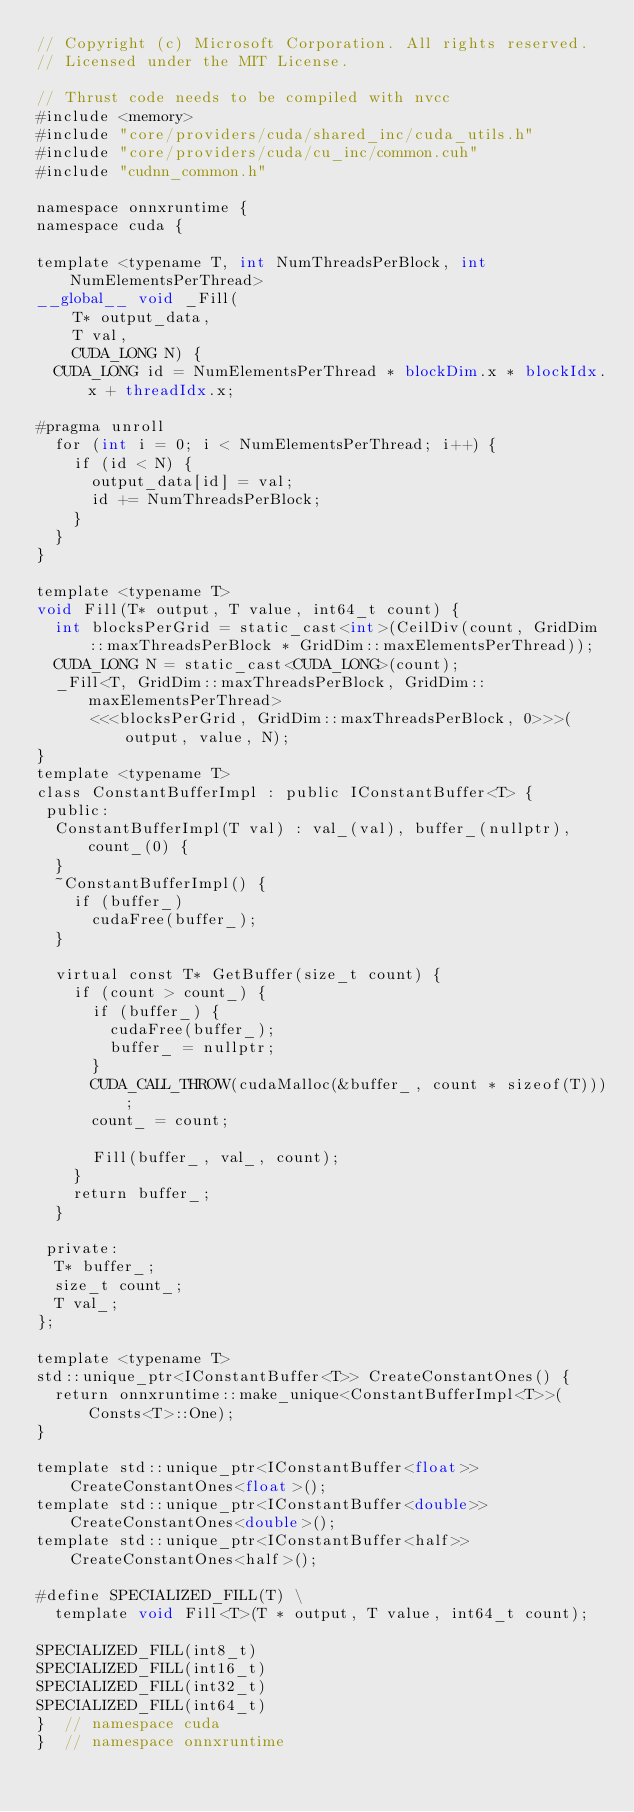<code> <loc_0><loc_0><loc_500><loc_500><_Cuda_>// Copyright (c) Microsoft Corporation. All rights reserved.
// Licensed under the MIT License.

// Thrust code needs to be compiled with nvcc
#include <memory>
#include "core/providers/cuda/shared_inc/cuda_utils.h"
#include "core/providers/cuda/cu_inc/common.cuh"
#include "cudnn_common.h"

namespace onnxruntime {
namespace cuda {

template <typename T, int NumThreadsPerBlock, int NumElementsPerThread>
__global__ void _Fill(
    T* output_data,
    T val,
    CUDA_LONG N) {
  CUDA_LONG id = NumElementsPerThread * blockDim.x * blockIdx.x + threadIdx.x;

#pragma unroll
  for (int i = 0; i < NumElementsPerThread; i++) {
    if (id < N) {
      output_data[id] = val;
      id += NumThreadsPerBlock;
    }
  }
}

template <typename T>
void Fill(T* output, T value, int64_t count) {
  int blocksPerGrid = static_cast<int>(CeilDiv(count, GridDim::maxThreadsPerBlock * GridDim::maxElementsPerThread));
  CUDA_LONG N = static_cast<CUDA_LONG>(count);
  _Fill<T, GridDim::maxThreadsPerBlock, GridDim::maxElementsPerThread>
      <<<blocksPerGrid, GridDim::maxThreadsPerBlock, 0>>>(output, value, N);
}
template <typename T>
class ConstantBufferImpl : public IConstantBuffer<T> {
 public:
  ConstantBufferImpl(T val) : val_(val), buffer_(nullptr), count_(0) {
  }
  ~ConstantBufferImpl() {
    if (buffer_)
      cudaFree(buffer_);
  }

  virtual const T* GetBuffer(size_t count) {
    if (count > count_) {
      if (buffer_) {
        cudaFree(buffer_);
        buffer_ = nullptr;
      }
      CUDA_CALL_THROW(cudaMalloc(&buffer_, count * sizeof(T)));
      count_ = count;

      Fill(buffer_, val_, count);
    }
    return buffer_;
  }

 private:
  T* buffer_;
  size_t count_;
  T val_;
};

template <typename T>
std::unique_ptr<IConstantBuffer<T>> CreateConstantOnes() {
  return onnxruntime::make_unique<ConstantBufferImpl<T>>(Consts<T>::One);
}

template std::unique_ptr<IConstantBuffer<float>> CreateConstantOnes<float>();
template std::unique_ptr<IConstantBuffer<double>> CreateConstantOnes<double>();
template std::unique_ptr<IConstantBuffer<half>> CreateConstantOnes<half>();

#define SPECIALIZED_FILL(T) \
  template void Fill<T>(T * output, T value, int64_t count);

SPECIALIZED_FILL(int8_t)
SPECIALIZED_FILL(int16_t)
SPECIALIZED_FILL(int32_t)
SPECIALIZED_FILL(int64_t)
}  // namespace cuda
}  // namespace onnxruntime
</code> 